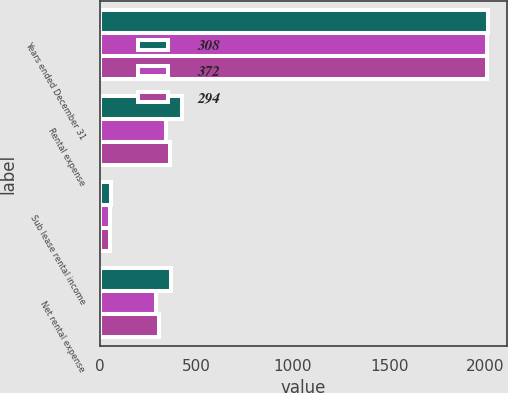<chart> <loc_0><loc_0><loc_500><loc_500><stacked_bar_chart><ecel><fcel>Years ended December 31<fcel>Rental expense<fcel>Sub lease rental income<fcel>Net rental expense<nl><fcel>308<fcel>2010<fcel>429<fcel>57<fcel>372<nl><fcel>372<fcel>2009<fcel>346<fcel>52<fcel>294<nl><fcel>294<fcel>2008<fcel>363<fcel>55<fcel>308<nl></chart> 